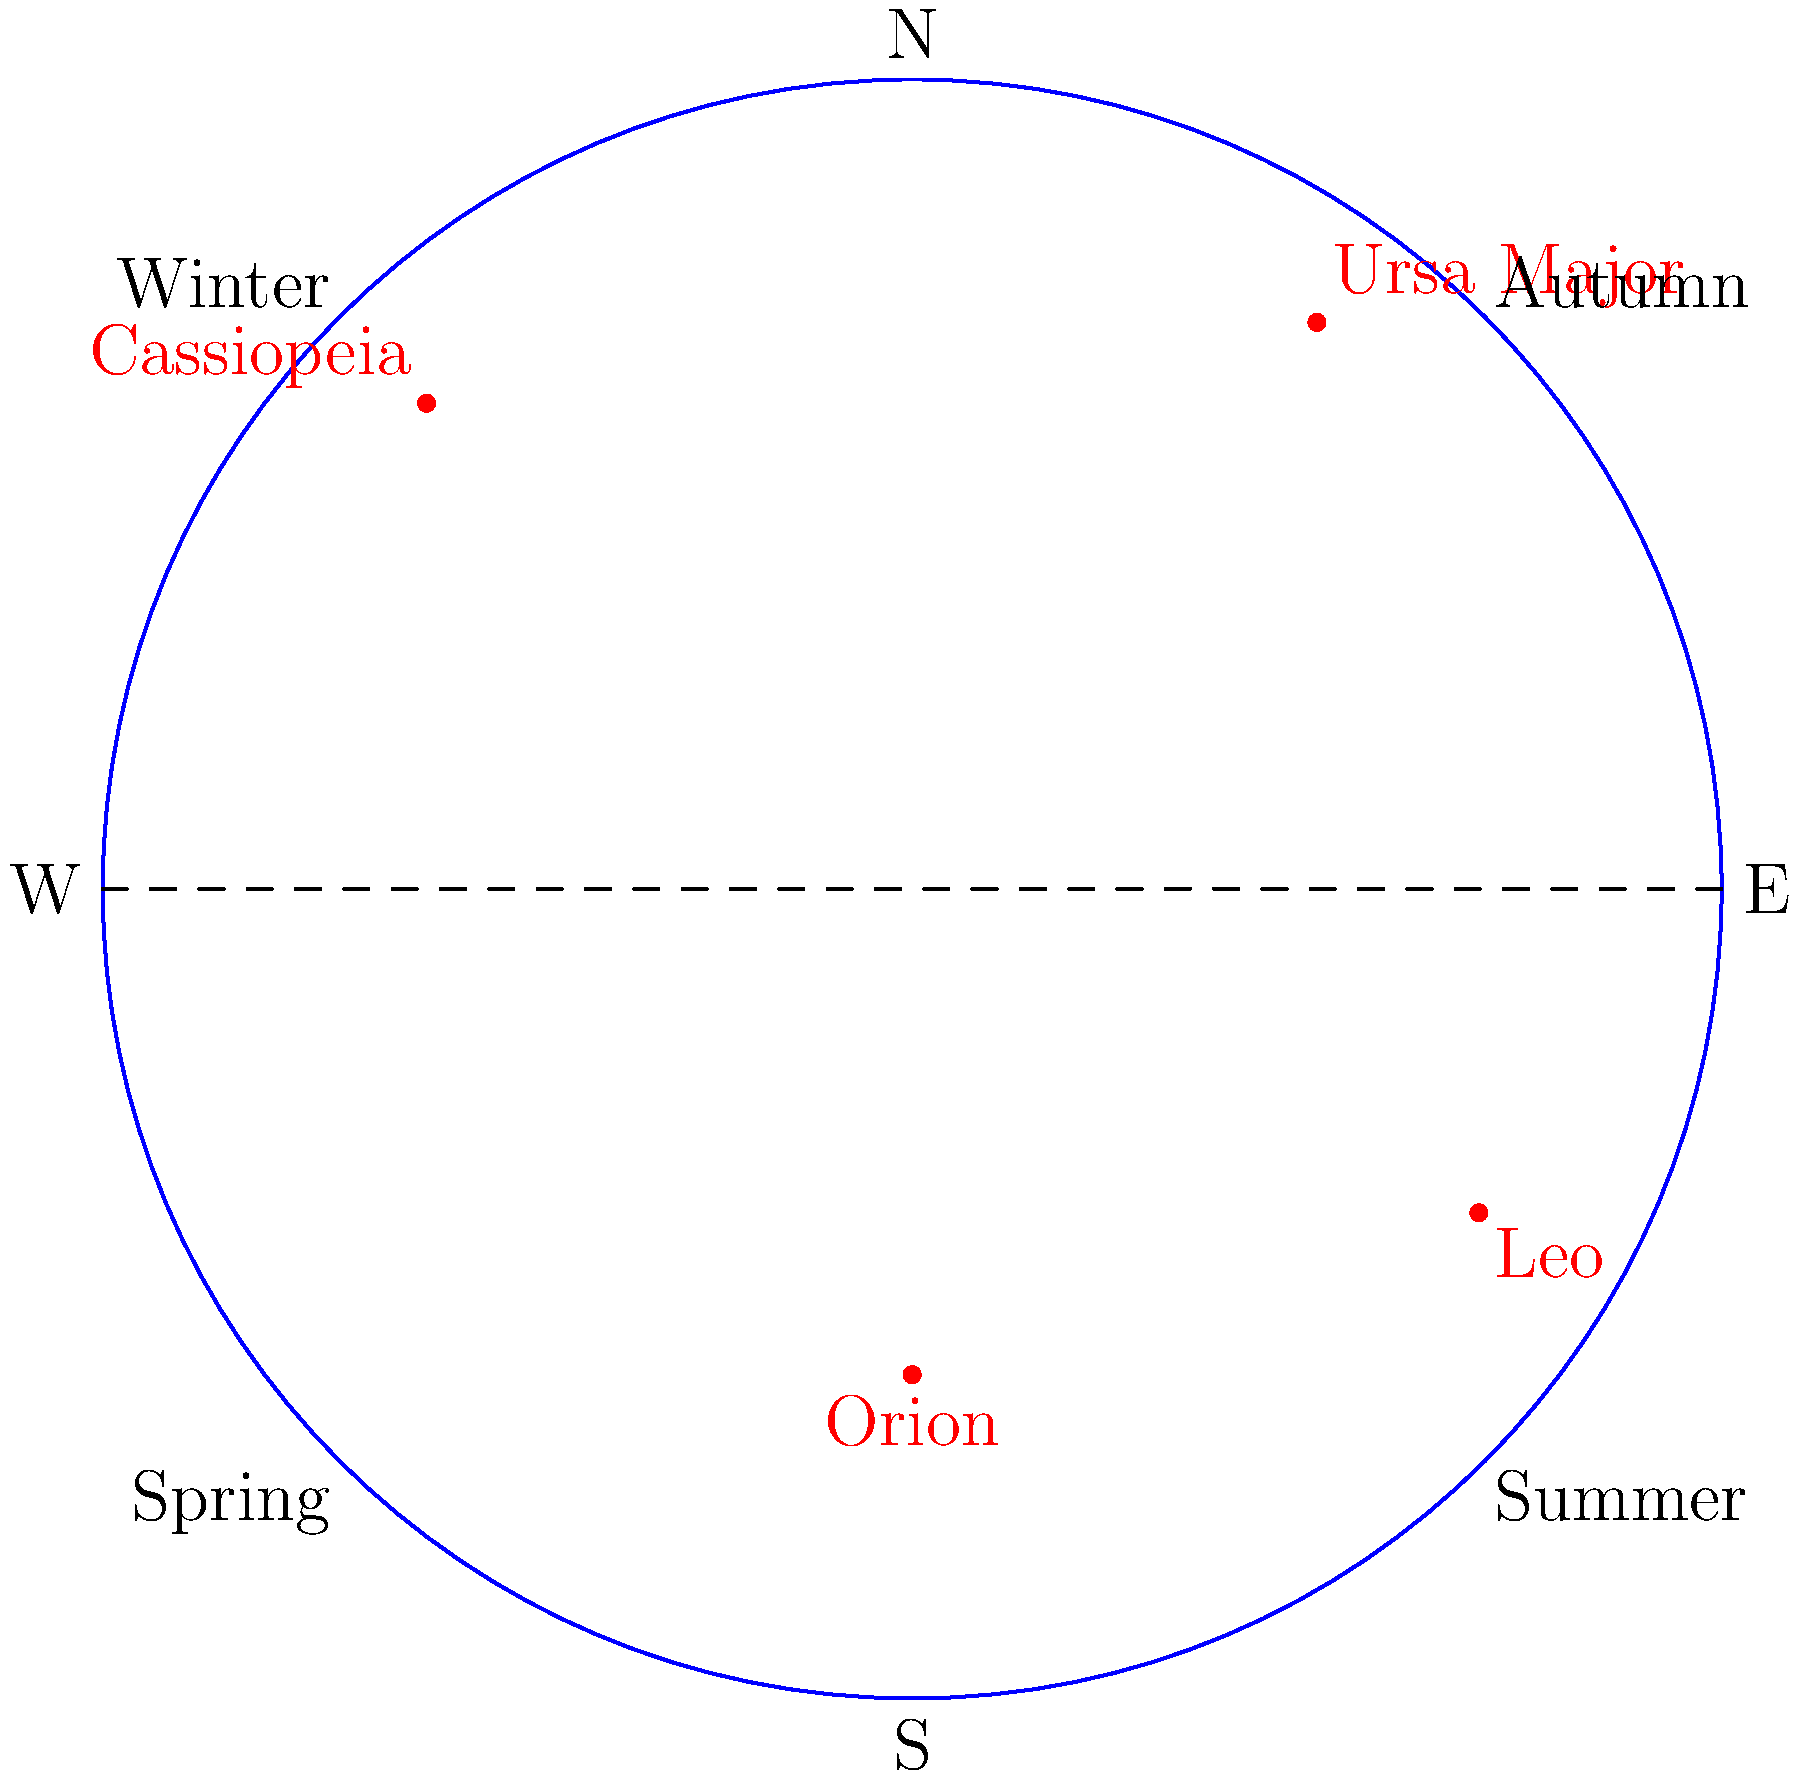As a parliamentarian concerned with promoting science education, you're preparing for a debate on the importance of astronomy in the national curriculum. Which of the constellations shown in this diagram of the night sky over the UK is visible throughout the year, regardless of the season? To answer this question, we need to consider the following steps:

1. Understand the diagram: The circle represents the night sky as seen from the UK, with cardinal directions and seasons marked.

2. Identify the constellations: The diagram shows Ursa Major, Cassiopeia, Orion, and Leo.

3. Consider the Earth's rotation and orbit:
   a. The Earth rotates on its axis, causing daily changes in visible constellations.
   b. The Earth orbits the Sun, causing seasonal changes in visible constellations.

4. Analyze constellation positions:
   a. Ursa Major and Cassiopeia are near the celestial North Pole.
   b. Orion and Leo are closer to the celestial equator.

5. Apply knowledge of circumpolar constellations:
   a. Constellations near the celestial pole that never set below the horizon are called circumpolar.
   b. For observers in the UK (northern hemisphere), circumpolar constellations are those close to the North Star (Polaris).

6. Identify circumpolar constellations:
   a. Ursa Major and Cassiopeia are positioned high in the northern sky.
   b. Their proximity to the North Star makes them circumpolar from the UK's latitude.

7. Eliminate seasonal constellations:
   a. Orion is visible in winter but not in summer.
   b. Leo is primarily a spring constellation.

Therefore, the constellations visible throughout the year from the UK, regardless of season, are Ursa Major and Cassiopeia.
Answer: Ursa Major and Cassiopeia 